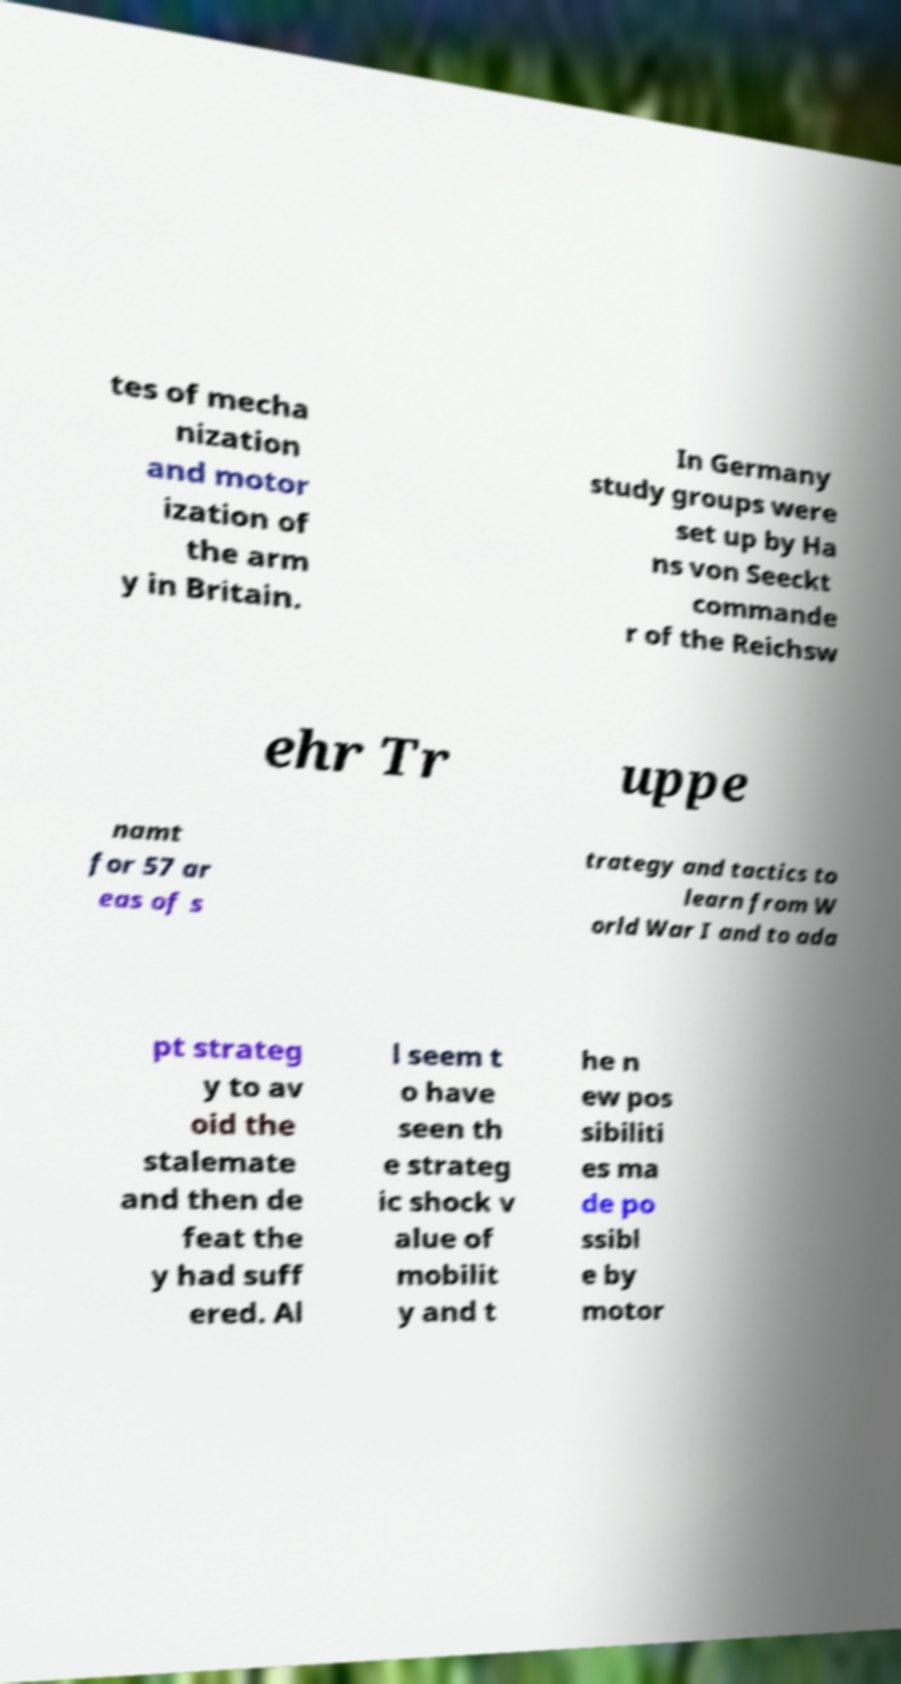Can you read and provide the text displayed in the image?This photo seems to have some interesting text. Can you extract and type it out for me? tes of mecha nization and motor ization of the arm y in Britain. In Germany study groups were set up by Ha ns von Seeckt commande r of the Reichsw ehr Tr uppe namt for 57 ar eas of s trategy and tactics to learn from W orld War I and to ada pt strateg y to av oid the stalemate and then de feat the y had suff ered. Al l seem t o have seen th e strateg ic shock v alue of mobilit y and t he n ew pos sibiliti es ma de po ssibl e by motor 